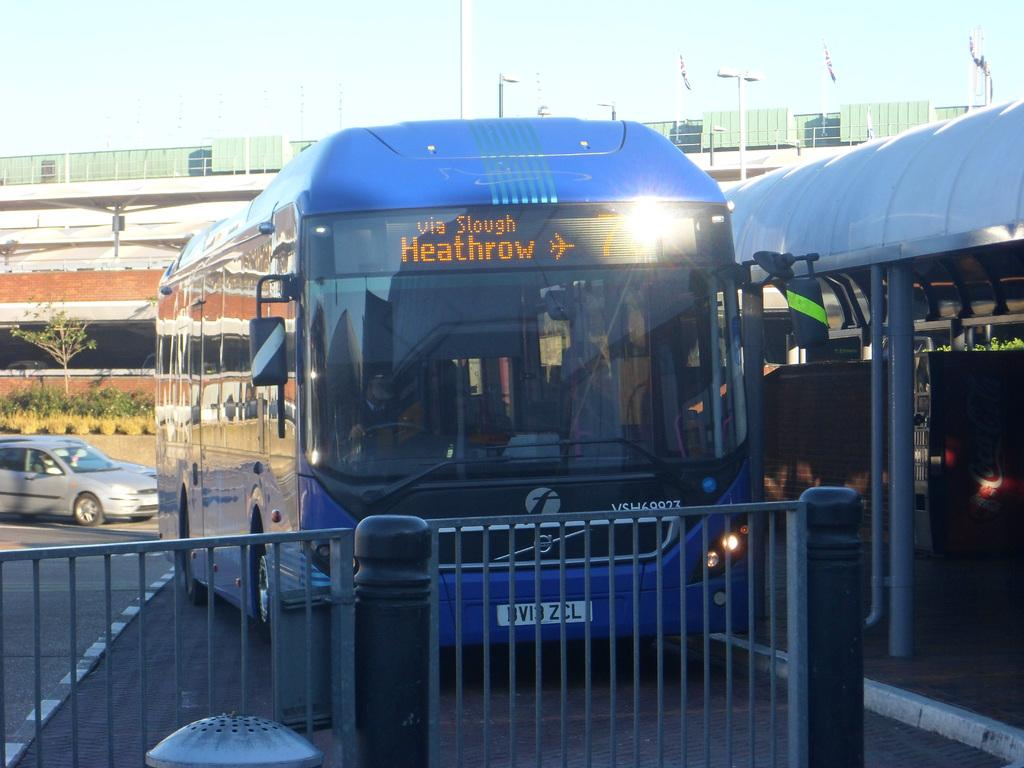<image>
Summarize the visual content of the image. Blue bus with the words Heathrow on it and a picture of an airplane. 